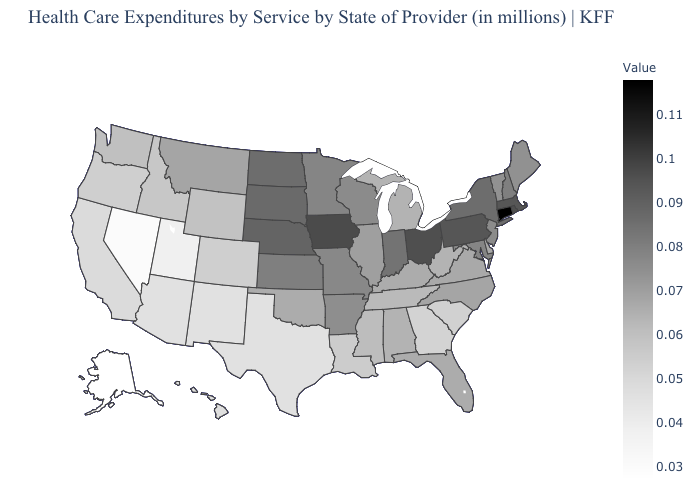Does Nebraska have a lower value than Maryland?
Quick response, please. No. Which states hav the highest value in the West?
Keep it brief. Montana. Does the map have missing data?
Concise answer only. No. Does the map have missing data?
Be succinct. No. 